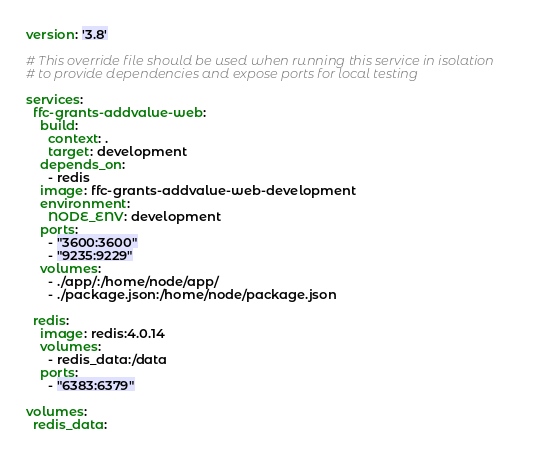Convert code to text. <code><loc_0><loc_0><loc_500><loc_500><_YAML_>version: '3.8'

# This override file should be used when running this service in isolation
# to provide dependencies and expose ports for local testing

services:
  ffc-grants-addvalue-web:
    build:
      context: .
      target: development
    depends_on:
      - redis
    image: ffc-grants-addvalue-web-development
    environment:
      NODE_ENV: development
    ports:
      - "3600:3600"
      - "9235:9229"
    volumes:
      - ./app/:/home/node/app/
      - ./package.json:/home/node/package.json

  redis:
    image: redis:4.0.14
    volumes:
      - redis_data:/data
    ports:
      - "6383:6379"

volumes:
  redis_data:
</code> 